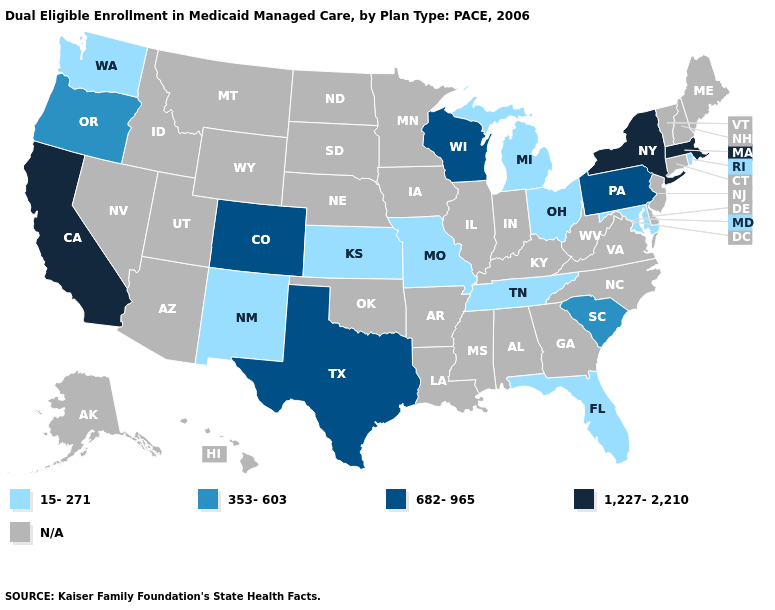Does Wisconsin have the lowest value in the MidWest?
Give a very brief answer. No. Does the map have missing data?
Concise answer only. Yes. What is the value of Nevada?
Answer briefly. N/A. What is the value of Virginia?
Answer briefly. N/A. Does Ohio have the lowest value in the USA?
Answer briefly. Yes. How many symbols are there in the legend?
Give a very brief answer. 5. How many symbols are there in the legend?
Concise answer only. 5. Is the legend a continuous bar?
Write a very short answer. No. What is the highest value in the USA?
Quick response, please. 1,227-2,210. How many symbols are there in the legend?
Short answer required. 5. Which states have the lowest value in the USA?
Concise answer only. Florida, Kansas, Maryland, Michigan, Missouri, New Mexico, Ohio, Rhode Island, Tennessee, Washington. What is the value of Alabama?
Keep it brief. N/A. Name the states that have a value in the range 1,227-2,210?
Keep it brief. California, Massachusetts, New York. Name the states that have a value in the range 15-271?
Quick response, please. Florida, Kansas, Maryland, Michigan, Missouri, New Mexico, Ohio, Rhode Island, Tennessee, Washington. 